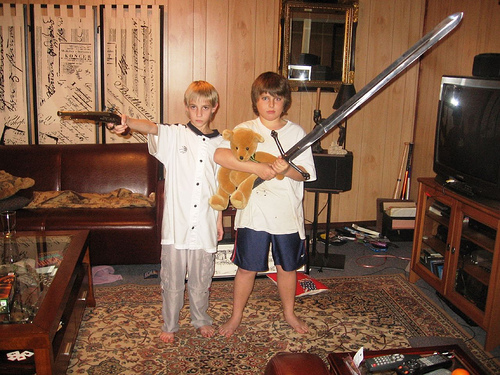How many televisions are in the photo? There is one television visible in the photo, located towards the right side of the image, on top of a media cabinet. 